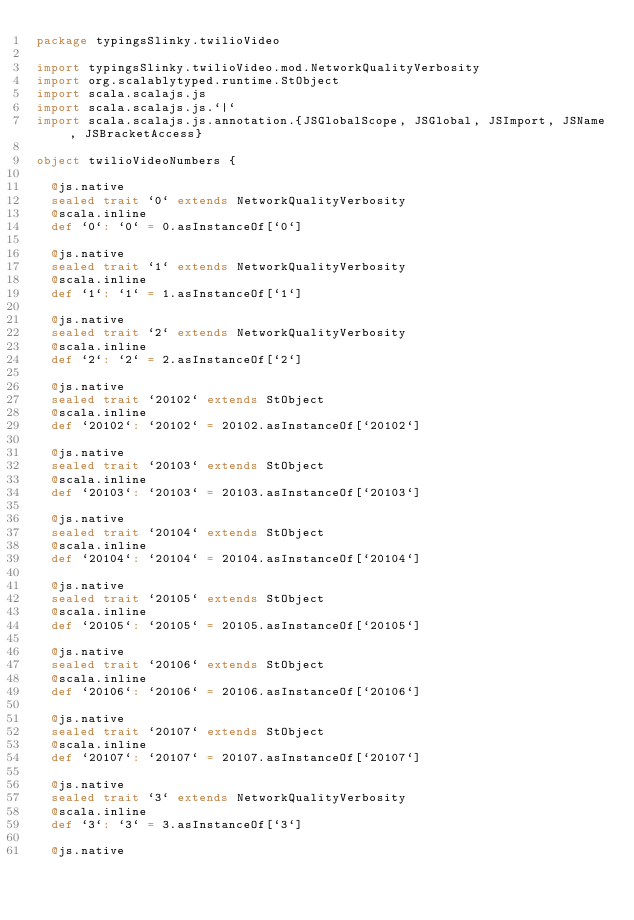Convert code to text. <code><loc_0><loc_0><loc_500><loc_500><_Scala_>package typingsSlinky.twilioVideo

import typingsSlinky.twilioVideo.mod.NetworkQualityVerbosity
import org.scalablytyped.runtime.StObject
import scala.scalajs.js
import scala.scalajs.js.`|`
import scala.scalajs.js.annotation.{JSGlobalScope, JSGlobal, JSImport, JSName, JSBracketAccess}

object twilioVideoNumbers {
  
  @js.native
  sealed trait `0` extends NetworkQualityVerbosity
  @scala.inline
  def `0`: `0` = 0.asInstanceOf[`0`]
  
  @js.native
  sealed trait `1` extends NetworkQualityVerbosity
  @scala.inline
  def `1`: `1` = 1.asInstanceOf[`1`]
  
  @js.native
  sealed trait `2` extends NetworkQualityVerbosity
  @scala.inline
  def `2`: `2` = 2.asInstanceOf[`2`]
  
  @js.native
  sealed trait `20102` extends StObject
  @scala.inline
  def `20102`: `20102` = 20102.asInstanceOf[`20102`]
  
  @js.native
  sealed trait `20103` extends StObject
  @scala.inline
  def `20103`: `20103` = 20103.asInstanceOf[`20103`]
  
  @js.native
  sealed trait `20104` extends StObject
  @scala.inline
  def `20104`: `20104` = 20104.asInstanceOf[`20104`]
  
  @js.native
  sealed trait `20105` extends StObject
  @scala.inline
  def `20105`: `20105` = 20105.asInstanceOf[`20105`]
  
  @js.native
  sealed trait `20106` extends StObject
  @scala.inline
  def `20106`: `20106` = 20106.asInstanceOf[`20106`]
  
  @js.native
  sealed trait `20107` extends StObject
  @scala.inline
  def `20107`: `20107` = 20107.asInstanceOf[`20107`]
  
  @js.native
  sealed trait `3` extends NetworkQualityVerbosity
  @scala.inline
  def `3`: `3` = 3.asInstanceOf[`3`]
  
  @js.native</code> 